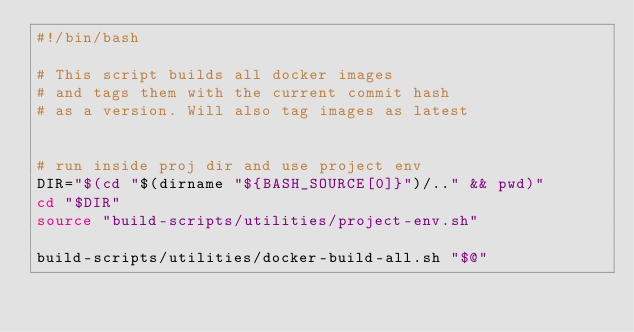Convert code to text. <code><loc_0><loc_0><loc_500><loc_500><_Bash_>#!/bin/bash

# This script builds all docker images
# and tags them with the current commit hash
# as a version. Will also tag images as latest


# run inside proj dir and use project env
DIR="$(cd "$(dirname "${BASH_SOURCE[0]}")/.." && pwd)"
cd "$DIR"
source "build-scripts/utilities/project-env.sh"

build-scripts/utilities/docker-build-all.sh "$@"


</code> 